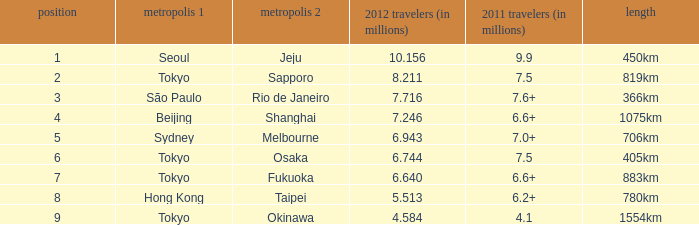In 2011, how many passengers (in millions) traveled on the route which saw 6.6+. 